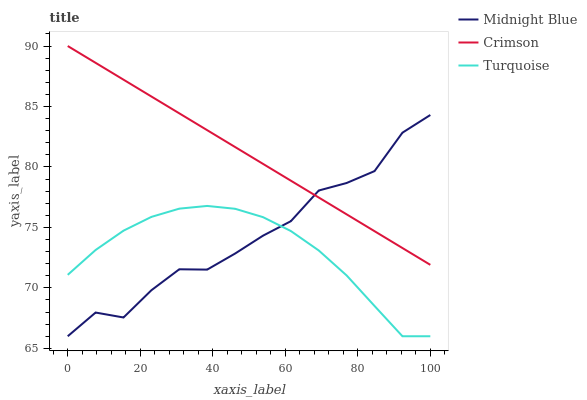Does Turquoise have the minimum area under the curve?
Answer yes or no. Yes. Does Crimson have the maximum area under the curve?
Answer yes or no. Yes. Does Midnight Blue have the minimum area under the curve?
Answer yes or no. No. Does Midnight Blue have the maximum area under the curve?
Answer yes or no. No. Is Crimson the smoothest?
Answer yes or no. Yes. Is Midnight Blue the roughest?
Answer yes or no. Yes. Is Turquoise the smoothest?
Answer yes or no. No. Is Turquoise the roughest?
Answer yes or no. No. Does Turquoise have the lowest value?
Answer yes or no. Yes. Does Crimson have the highest value?
Answer yes or no. Yes. Does Midnight Blue have the highest value?
Answer yes or no. No. Is Turquoise less than Crimson?
Answer yes or no. Yes. Is Crimson greater than Turquoise?
Answer yes or no. Yes. Does Turquoise intersect Midnight Blue?
Answer yes or no. Yes. Is Turquoise less than Midnight Blue?
Answer yes or no. No. Is Turquoise greater than Midnight Blue?
Answer yes or no. No. Does Turquoise intersect Crimson?
Answer yes or no. No. 